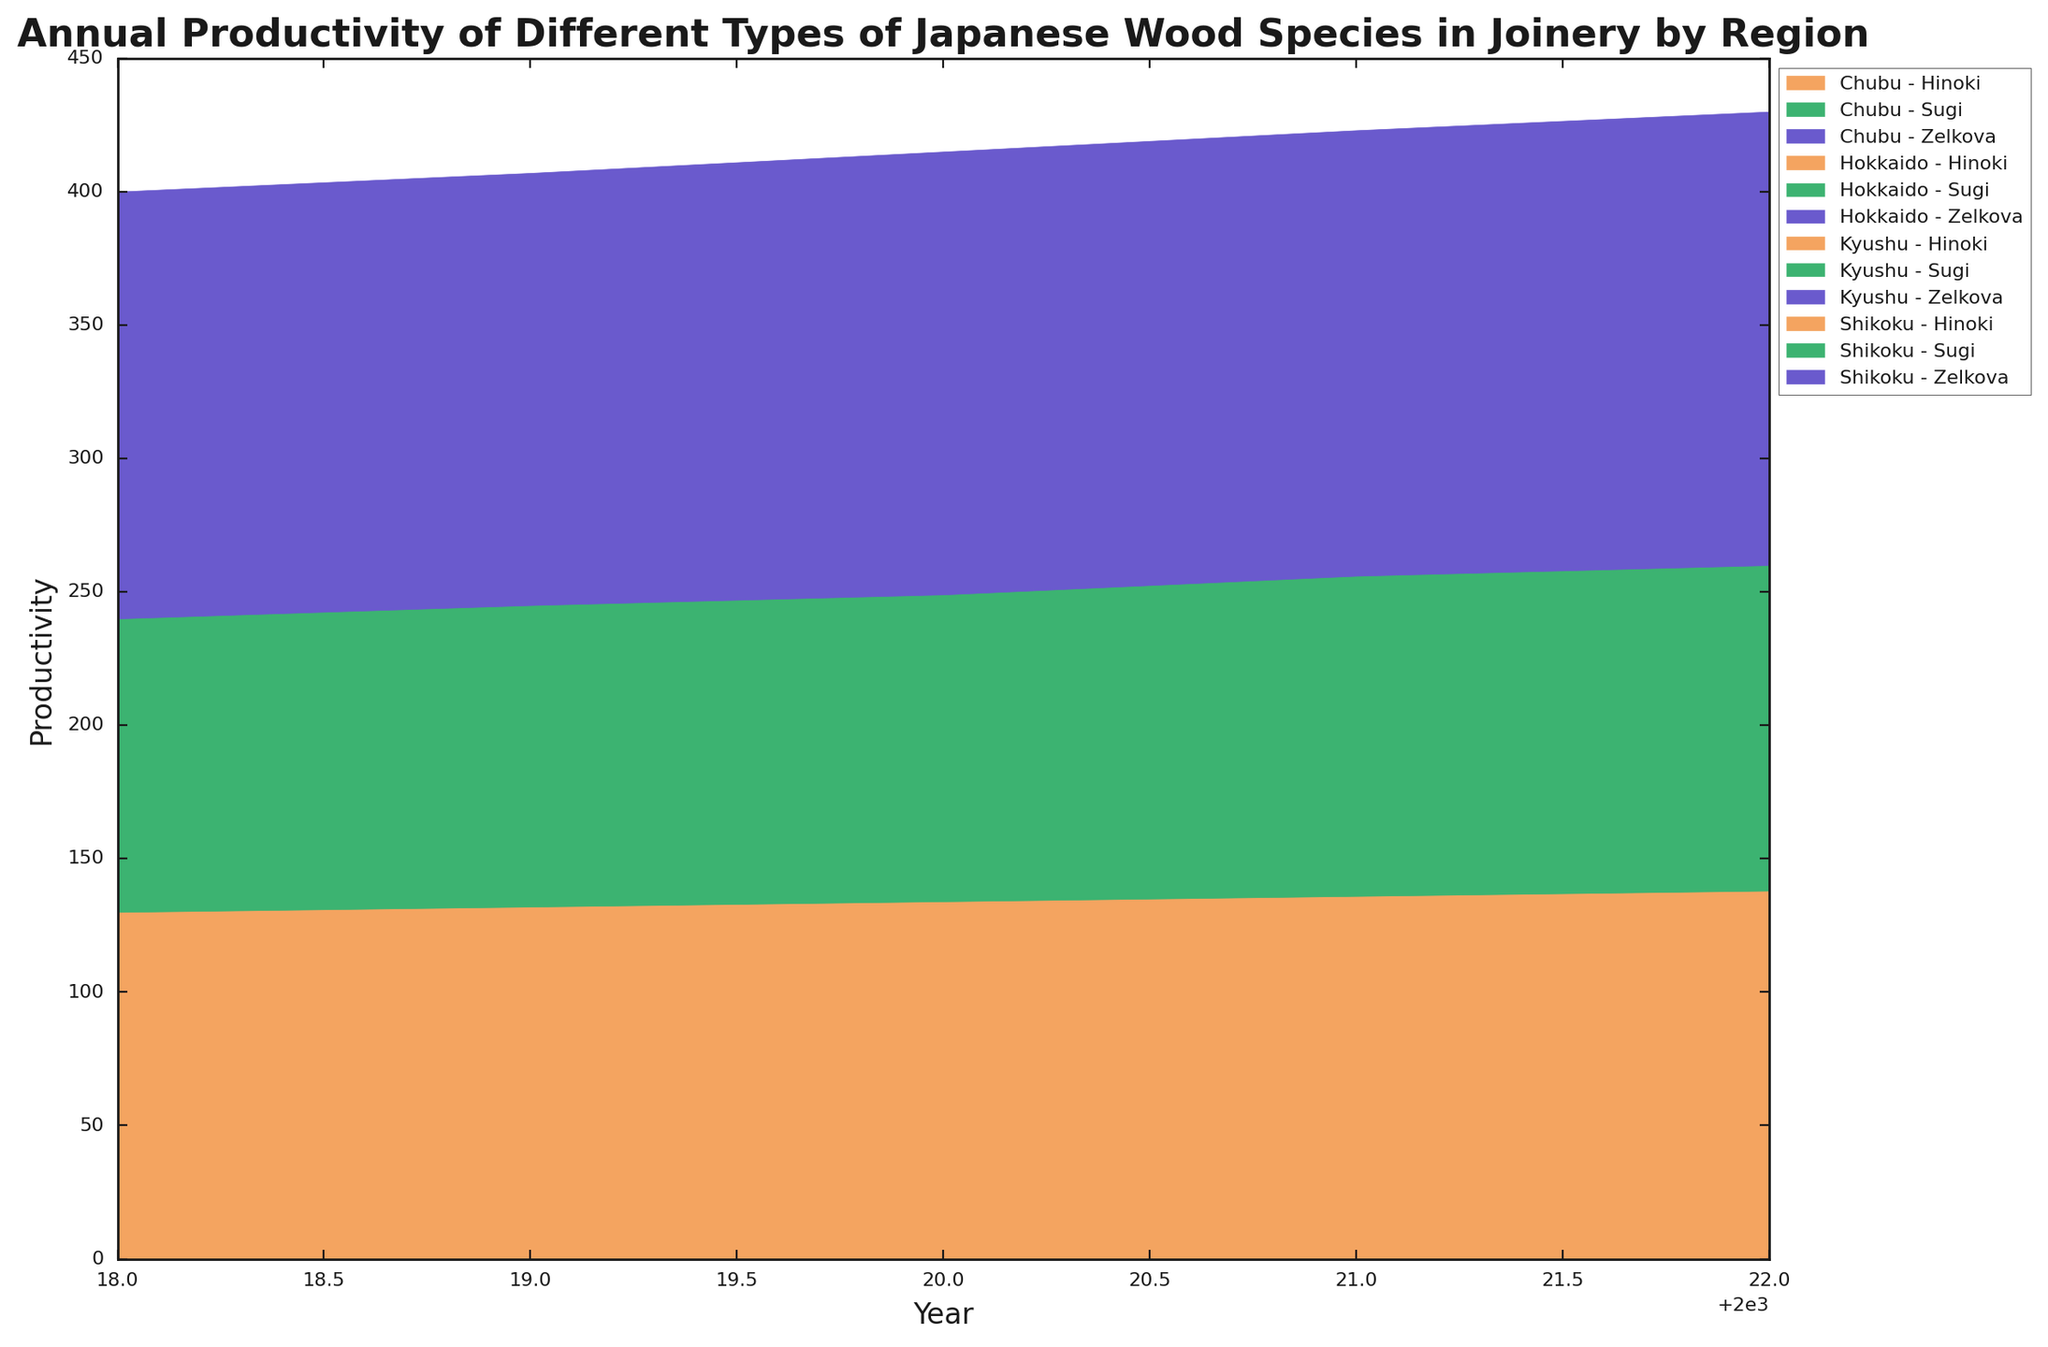Which region had the highest productivity of Hinoki wood in 2022? To find the region with the highest productivity for Hinoki wood in 2022, locate the 2022 data on the x-axis, and compare the productivity of Hinoki wood across different regions. Kyushu had the highest height for Hinoki wood among the regions.
Answer: Kyushu Compare the productivity of Sugi wood in Kyushu and Chubu regions in 2020. Which one is higher? Locate the 2020 data on the x-axis, find the segments for Sugi wood in the Kyushu and Chubu regions, and compare their heights. Sugi wood in Kyushu has a higher height than in Chubu.
Answer: Kyushu What is the trend of Zelkova wood productivity in Hokkaido from 2018 to 2022? Look across the years 2018 to 2022 for Hokkaido and observe the height of the Zelkova wood section. The trend shows a gradual increase from 2018 to 2022.
Answer: Increasing What's the total productivity of all three wood species in Shikoku in 2021? Find the 2021 data and sum the heights of Hinoki, Sugi, and Zelkova wood species for the Shikoku region. Summing the individual parts gives the total productivity.
Answer: 346 How does the productivity of Hinoki wood in Chubu in 2019 compare to 2021? Compare the heights of Hinoki wood segments for Chubu in 2019 and 2021. The height in 2021 is higher than in 2019.
Answer: Higher in 2021 Which species had the smallest increase in productivity in Hokkaido from 2018 to 2022? Inspect the change in height for each species in Hokkaido from 2018 to 2022. Zelkova shows the smallest increase compared to Hinoki and Sugi.
Answer: Zelkova What's the sum of Sugi wood productivity across all regions in 2020? Locate the 2020 data, identify the heights of the Sugi wood sections in all regions, and add them up to get the total productivity.
Answer: 526 How did the productivity of Zelkova wood in Kyushu change from 2018 to 2022? Quantify the increase. Find the 2018 and 2022 productivity data for Zelkova wood in Kyushu and calculate the difference (110 - 100) to quantify the increase.
Answer: Increased by 10 